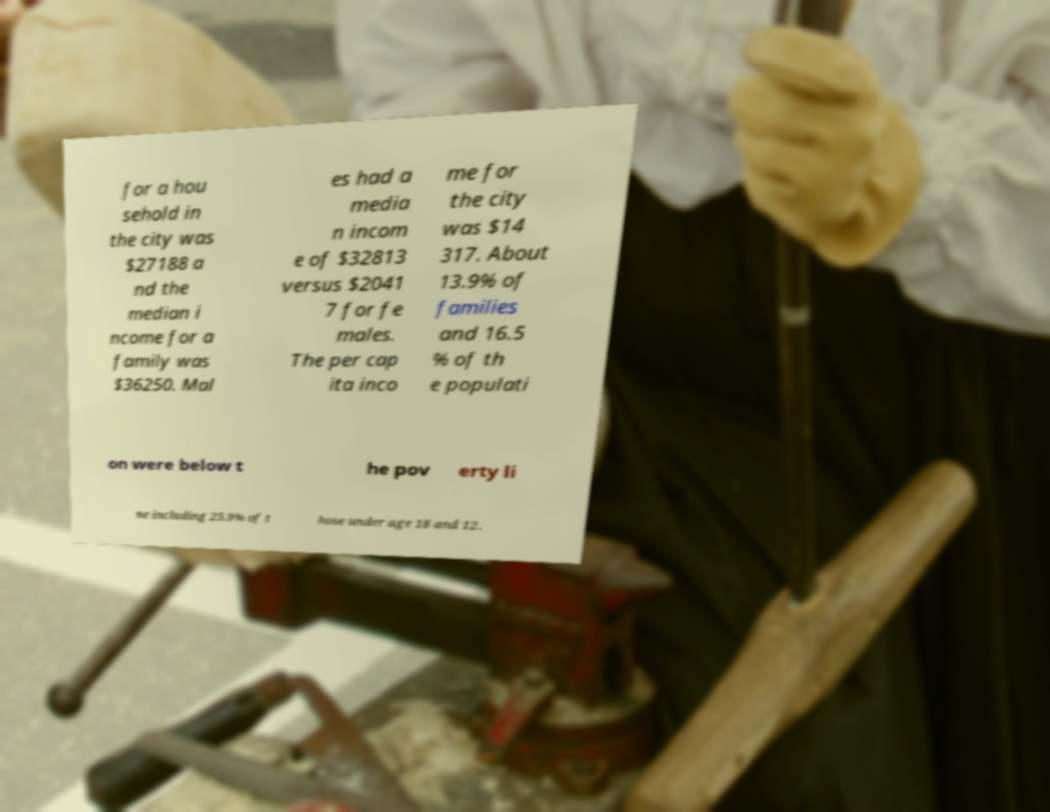There's text embedded in this image that I need extracted. Can you transcribe it verbatim? for a hou sehold in the city was $27188 a nd the median i ncome for a family was $36250. Mal es had a media n incom e of $32813 versus $2041 7 for fe males. The per cap ita inco me for the city was $14 317. About 13.9% of families and 16.5 % of th e populati on were below t he pov erty li ne including 25.9% of t hose under age 18 and 12. 